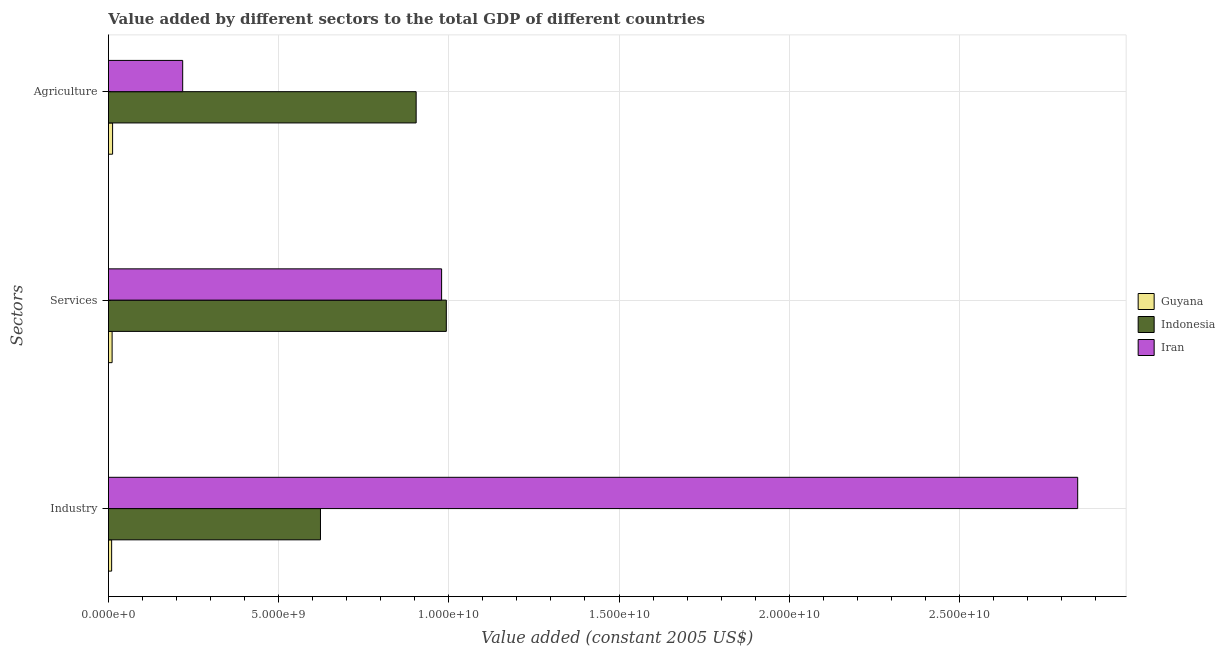How many groups of bars are there?
Offer a very short reply. 3. Are the number of bars on each tick of the Y-axis equal?
Your response must be concise. Yes. How many bars are there on the 2nd tick from the top?
Your answer should be very brief. 3. What is the label of the 2nd group of bars from the top?
Keep it short and to the point. Services. What is the value added by agricultural sector in Guyana?
Give a very brief answer. 1.22e+08. Across all countries, what is the maximum value added by agricultural sector?
Your answer should be very brief. 9.04e+09. Across all countries, what is the minimum value added by industrial sector?
Offer a terse response. 9.43e+07. In which country was the value added by services minimum?
Make the answer very short. Guyana. What is the total value added by services in the graph?
Offer a very short reply. 1.98e+1. What is the difference between the value added by agricultural sector in Indonesia and that in Iran?
Your answer should be very brief. 6.86e+09. What is the difference between the value added by services in Indonesia and the value added by industrial sector in Iran?
Give a very brief answer. -1.85e+1. What is the average value added by agricultural sector per country?
Ensure brevity in your answer.  3.78e+09. What is the difference between the value added by agricultural sector and value added by industrial sector in Iran?
Offer a very short reply. -2.63e+1. In how many countries, is the value added by services greater than 26000000000 US$?
Make the answer very short. 0. What is the ratio of the value added by services in Guyana to that in Iran?
Your answer should be very brief. 0.01. Is the value added by agricultural sector in Iran less than that in Indonesia?
Your response must be concise. Yes. What is the difference between the highest and the second highest value added by services?
Provide a short and direct response. 1.38e+08. What is the difference between the highest and the lowest value added by services?
Provide a succinct answer. 9.82e+09. In how many countries, is the value added by services greater than the average value added by services taken over all countries?
Provide a succinct answer. 2. What does the 3rd bar from the top in Industry represents?
Make the answer very short. Guyana. What does the 3rd bar from the bottom in Industry represents?
Your answer should be very brief. Iran. Are all the bars in the graph horizontal?
Offer a terse response. Yes. How many countries are there in the graph?
Ensure brevity in your answer.  3. What is the difference between two consecutive major ticks on the X-axis?
Your response must be concise. 5.00e+09. Are the values on the major ticks of X-axis written in scientific E-notation?
Your response must be concise. Yes. Does the graph contain any zero values?
Offer a very short reply. No. How many legend labels are there?
Offer a very short reply. 3. How are the legend labels stacked?
Give a very brief answer. Vertical. What is the title of the graph?
Provide a succinct answer. Value added by different sectors to the total GDP of different countries. What is the label or title of the X-axis?
Your answer should be very brief. Value added (constant 2005 US$). What is the label or title of the Y-axis?
Provide a succinct answer. Sectors. What is the Value added (constant 2005 US$) of Guyana in Industry?
Your response must be concise. 9.43e+07. What is the Value added (constant 2005 US$) in Indonesia in Industry?
Ensure brevity in your answer.  6.23e+09. What is the Value added (constant 2005 US$) of Iran in Industry?
Offer a terse response. 2.85e+1. What is the Value added (constant 2005 US$) in Guyana in Services?
Ensure brevity in your answer.  1.08e+08. What is the Value added (constant 2005 US$) in Indonesia in Services?
Keep it short and to the point. 9.93e+09. What is the Value added (constant 2005 US$) of Iran in Services?
Provide a succinct answer. 9.79e+09. What is the Value added (constant 2005 US$) in Guyana in Agriculture?
Provide a succinct answer. 1.22e+08. What is the Value added (constant 2005 US$) in Indonesia in Agriculture?
Your answer should be very brief. 9.04e+09. What is the Value added (constant 2005 US$) in Iran in Agriculture?
Provide a short and direct response. 2.18e+09. Across all Sectors, what is the maximum Value added (constant 2005 US$) of Guyana?
Ensure brevity in your answer.  1.22e+08. Across all Sectors, what is the maximum Value added (constant 2005 US$) of Indonesia?
Ensure brevity in your answer.  9.93e+09. Across all Sectors, what is the maximum Value added (constant 2005 US$) of Iran?
Offer a very short reply. 2.85e+1. Across all Sectors, what is the minimum Value added (constant 2005 US$) of Guyana?
Provide a short and direct response. 9.43e+07. Across all Sectors, what is the minimum Value added (constant 2005 US$) in Indonesia?
Keep it short and to the point. 6.23e+09. Across all Sectors, what is the minimum Value added (constant 2005 US$) in Iran?
Your answer should be very brief. 2.18e+09. What is the total Value added (constant 2005 US$) in Guyana in the graph?
Keep it short and to the point. 3.25e+08. What is the total Value added (constant 2005 US$) of Indonesia in the graph?
Your answer should be compact. 2.52e+1. What is the total Value added (constant 2005 US$) of Iran in the graph?
Ensure brevity in your answer.  4.04e+1. What is the difference between the Value added (constant 2005 US$) of Guyana in Industry and that in Services?
Offer a very short reply. -1.39e+07. What is the difference between the Value added (constant 2005 US$) of Indonesia in Industry and that in Services?
Give a very brief answer. -3.70e+09. What is the difference between the Value added (constant 2005 US$) in Iran in Industry and that in Services?
Your response must be concise. 1.87e+1. What is the difference between the Value added (constant 2005 US$) in Guyana in Industry and that in Agriculture?
Offer a very short reply. -2.79e+07. What is the difference between the Value added (constant 2005 US$) in Indonesia in Industry and that in Agriculture?
Offer a very short reply. -2.81e+09. What is the difference between the Value added (constant 2005 US$) in Iran in Industry and that in Agriculture?
Your response must be concise. 2.63e+1. What is the difference between the Value added (constant 2005 US$) in Guyana in Services and that in Agriculture?
Provide a succinct answer. -1.40e+07. What is the difference between the Value added (constant 2005 US$) in Indonesia in Services and that in Agriculture?
Keep it short and to the point. 8.86e+08. What is the difference between the Value added (constant 2005 US$) of Iran in Services and that in Agriculture?
Provide a short and direct response. 7.61e+09. What is the difference between the Value added (constant 2005 US$) in Guyana in Industry and the Value added (constant 2005 US$) in Indonesia in Services?
Provide a short and direct response. -9.83e+09. What is the difference between the Value added (constant 2005 US$) in Guyana in Industry and the Value added (constant 2005 US$) in Iran in Services?
Your answer should be compact. -9.69e+09. What is the difference between the Value added (constant 2005 US$) in Indonesia in Industry and the Value added (constant 2005 US$) in Iran in Services?
Keep it short and to the point. -3.56e+09. What is the difference between the Value added (constant 2005 US$) of Guyana in Industry and the Value added (constant 2005 US$) of Indonesia in Agriculture?
Your answer should be compact. -8.95e+09. What is the difference between the Value added (constant 2005 US$) of Guyana in Industry and the Value added (constant 2005 US$) of Iran in Agriculture?
Keep it short and to the point. -2.09e+09. What is the difference between the Value added (constant 2005 US$) of Indonesia in Industry and the Value added (constant 2005 US$) of Iran in Agriculture?
Give a very brief answer. 4.05e+09. What is the difference between the Value added (constant 2005 US$) in Guyana in Services and the Value added (constant 2005 US$) in Indonesia in Agriculture?
Make the answer very short. -8.93e+09. What is the difference between the Value added (constant 2005 US$) in Guyana in Services and the Value added (constant 2005 US$) in Iran in Agriculture?
Your answer should be compact. -2.07e+09. What is the difference between the Value added (constant 2005 US$) of Indonesia in Services and the Value added (constant 2005 US$) of Iran in Agriculture?
Provide a short and direct response. 7.75e+09. What is the average Value added (constant 2005 US$) in Guyana per Sectors?
Make the answer very short. 1.08e+08. What is the average Value added (constant 2005 US$) in Indonesia per Sectors?
Your answer should be compact. 8.40e+09. What is the average Value added (constant 2005 US$) of Iran per Sectors?
Your answer should be very brief. 1.35e+1. What is the difference between the Value added (constant 2005 US$) of Guyana and Value added (constant 2005 US$) of Indonesia in Industry?
Keep it short and to the point. -6.13e+09. What is the difference between the Value added (constant 2005 US$) in Guyana and Value added (constant 2005 US$) in Iran in Industry?
Offer a terse response. -2.84e+1. What is the difference between the Value added (constant 2005 US$) of Indonesia and Value added (constant 2005 US$) of Iran in Industry?
Offer a very short reply. -2.22e+1. What is the difference between the Value added (constant 2005 US$) in Guyana and Value added (constant 2005 US$) in Indonesia in Services?
Provide a succinct answer. -9.82e+09. What is the difference between the Value added (constant 2005 US$) in Guyana and Value added (constant 2005 US$) in Iran in Services?
Provide a succinct answer. -9.68e+09. What is the difference between the Value added (constant 2005 US$) in Indonesia and Value added (constant 2005 US$) in Iran in Services?
Keep it short and to the point. 1.38e+08. What is the difference between the Value added (constant 2005 US$) of Guyana and Value added (constant 2005 US$) of Indonesia in Agriculture?
Offer a very short reply. -8.92e+09. What is the difference between the Value added (constant 2005 US$) in Guyana and Value added (constant 2005 US$) in Iran in Agriculture?
Your answer should be compact. -2.06e+09. What is the difference between the Value added (constant 2005 US$) of Indonesia and Value added (constant 2005 US$) of Iran in Agriculture?
Keep it short and to the point. 6.86e+09. What is the ratio of the Value added (constant 2005 US$) in Guyana in Industry to that in Services?
Your response must be concise. 0.87. What is the ratio of the Value added (constant 2005 US$) in Indonesia in Industry to that in Services?
Your answer should be compact. 0.63. What is the ratio of the Value added (constant 2005 US$) in Iran in Industry to that in Services?
Provide a short and direct response. 2.91. What is the ratio of the Value added (constant 2005 US$) in Guyana in Industry to that in Agriculture?
Give a very brief answer. 0.77. What is the ratio of the Value added (constant 2005 US$) in Indonesia in Industry to that in Agriculture?
Provide a succinct answer. 0.69. What is the ratio of the Value added (constant 2005 US$) of Iran in Industry to that in Agriculture?
Provide a succinct answer. 13.05. What is the ratio of the Value added (constant 2005 US$) in Guyana in Services to that in Agriculture?
Provide a short and direct response. 0.89. What is the ratio of the Value added (constant 2005 US$) in Indonesia in Services to that in Agriculture?
Your answer should be very brief. 1.1. What is the ratio of the Value added (constant 2005 US$) in Iran in Services to that in Agriculture?
Your response must be concise. 4.49. What is the difference between the highest and the second highest Value added (constant 2005 US$) of Guyana?
Provide a succinct answer. 1.40e+07. What is the difference between the highest and the second highest Value added (constant 2005 US$) in Indonesia?
Offer a terse response. 8.86e+08. What is the difference between the highest and the second highest Value added (constant 2005 US$) in Iran?
Give a very brief answer. 1.87e+1. What is the difference between the highest and the lowest Value added (constant 2005 US$) of Guyana?
Your answer should be compact. 2.79e+07. What is the difference between the highest and the lowest Value added (constant 2005 US$) in Indonesia?
Make the answer very short. 3.70e+09. What is the difference between the highest and the lowest Value added (constant 2005 US$) of Iran?
Make the answer very short. 2.63e+1. 